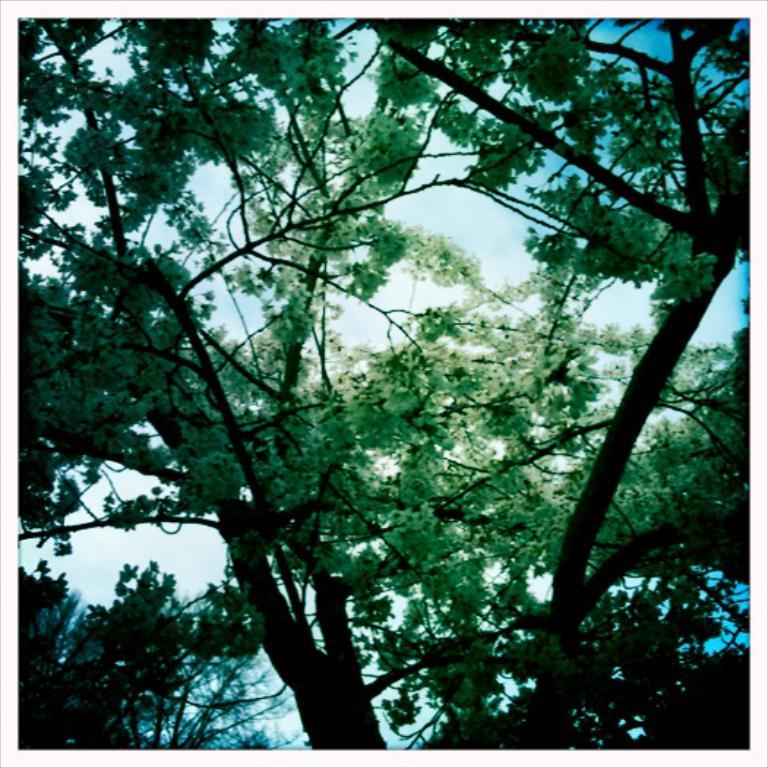What type of vegetation can be seen in the image? There are trees in the image. What part of the natural environment is visible in the image? The sky is visible in the background of the image. What type of mask is being worn by the tree in the image? There are no masks present in the image, as it features trees and the sky. 